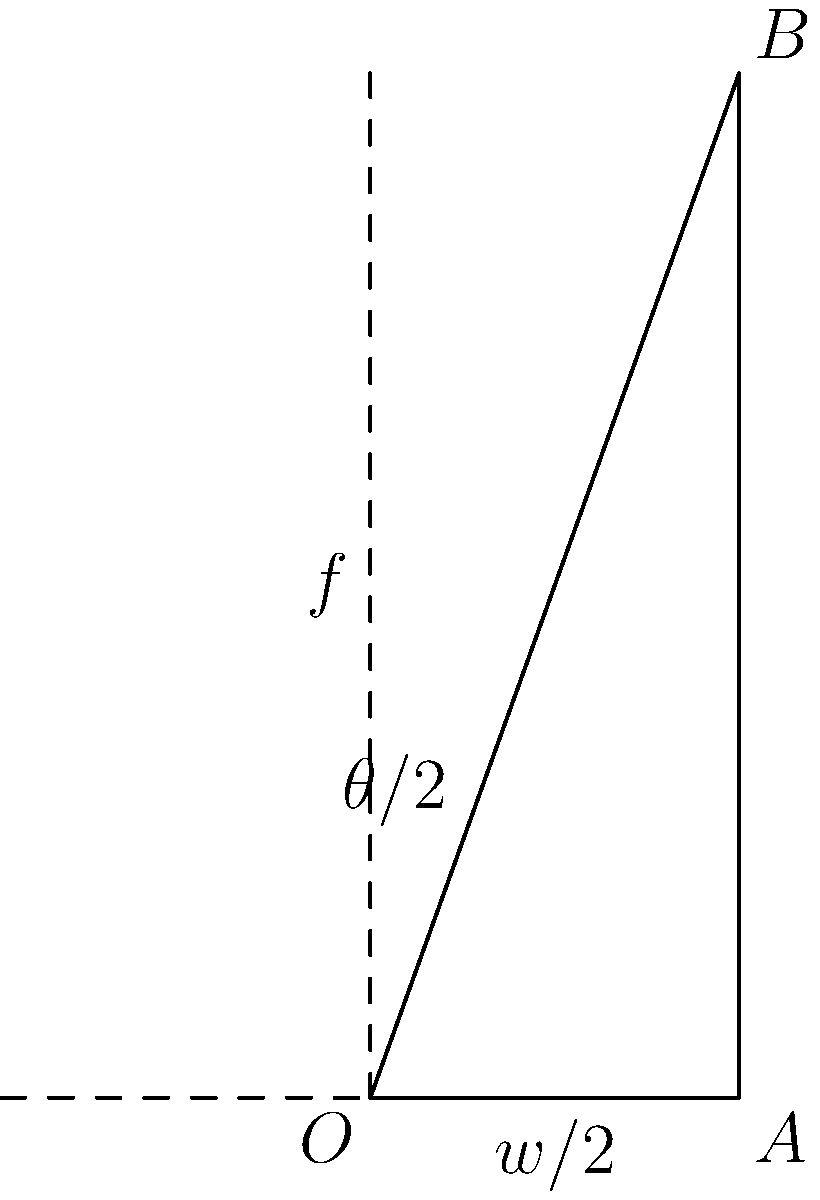As a landscape photographer, you're considering a new full-frame camera with a 36mm wide sensor. If you use a 50mm lens, what would be the horizontal angle of view? Provide your answer in degrees, rounded to the nearest whole number. To calculate the horizontal angle of view, we'll follow these steps:

1) The formula for the angle of view is:

   $$\theta = 2 \arctan(\frac{d}{2f})$$

   Where $\theta$ is the angle of view, $d$ is the sensor dimension (width in this case), and $f$ is the focal length.

2) We're given:
   - Sensor width ($d$) = 36mm
   - Focal length ($f$) = 50mm

3) Plugging these values into our formula:

   $$\theta = 2 \arctan(\frac{36}{2 \times 50})$$

4) Simplify inside the parentheses:

   $$\theta = 2 \arctan(\frac{18}{50})$$

5) Calculate the arctangent:

   $$\theta = 2 \times 0.3463 \text{ radians}$$

6) Multiply:

   $$\theta = 0.6926 \text{ radians}$$

7) Convert to degrees:

   $$\theta = 0.6926 \times \frac{180}{\pi} = 39.6^\circ$$

8) Rounding to the nearest whole number:

   $$\theta \approx 40^\circ$$

Therefore, the horizontal angle of view is approximately 40 degrees.
Answer: 40° 